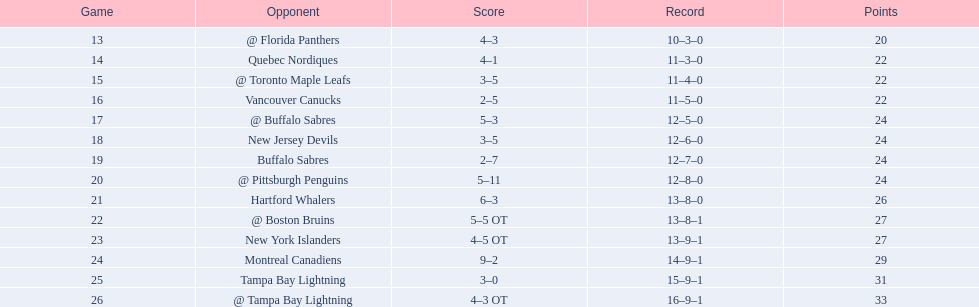Who did the philadelphia flyers play in game 17? @ Buffalo Sabres. What was the score of the november 10th game against the buffalo sabres? 5–3. Which team in the atlantic division had less points than the philadelphia flyers? Tampa Bay Lightning. 